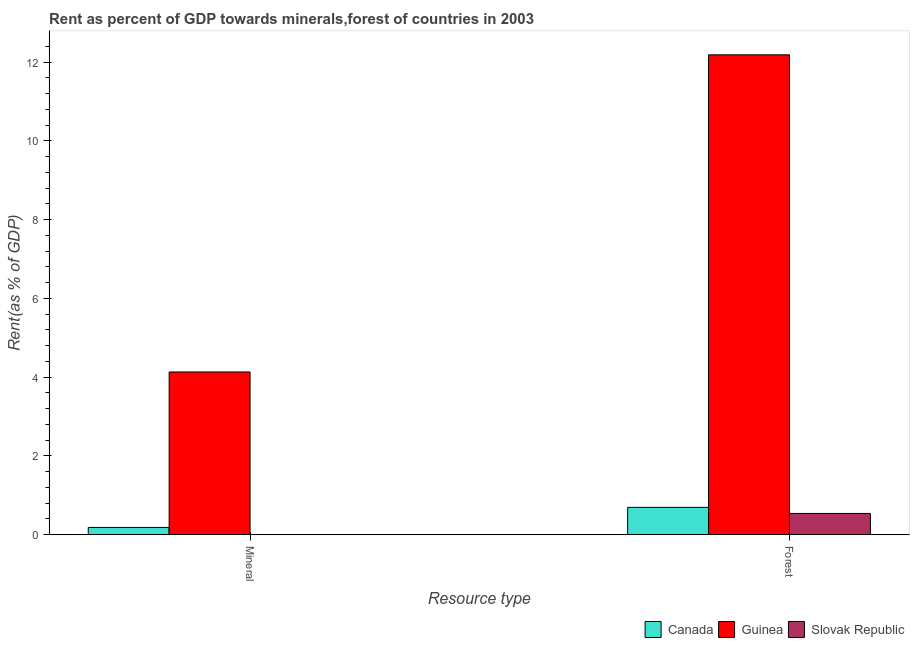How many bars are there on the 1st tick from the right?
Your response must be concise. 3. What is the label of the 1st group of bars from the left?
Your answer should be compact. Mineral. What is the forest rent in Guinea?
Keep it short and to the point. 12.18. Across all countries, what is the maximum mineral rent?
Your answer should be very brief. 4.13. Across all countries, what is the minimum forest rent?
Your answer should be compact. 0.54. In which country was the forest rent maximum?
Your answer should be very brief. Guinea. In which country was the mineral rent minimum?
Your response must be concise. Slovak Republic. What is the total mineral rent in the graph?
Offer a terse response. 4.32. What is the difference between the forest rent in Canada and that in Slovak Republic?
Provide a short and direct response. 0.15. What is the difference between the forest rent in Slovak Republic and the mineral rent in Guinea?
Provide a succinct answer. -3.59. What is the average forest rent per country?
Make the answer very short. 4.47. What is the difference between the mineral rent and forest rent in Guinea?
Offer a very short reply. -8.05. In how many countries, is the forest rent greater than 5.6 %?
Make the answer very short. 1. What is the ratio of the forest rent in Canada to that in Guinea?
Your response must be concise. 0.06. In how many countries, is the mineral rent greater than the average mineral rent taken over all countries?
Ensure brevity in your answer.  1. What does the 3rd bar from the left in Mineral represents?
Give a very brief answer. Slovak Republic. What does the 2nd bar from the right in Mineral represents?
Your answer should be compact. Guinea. How many bars are there?
Your answer should be compact. 6. How many countries are there in the graph?
Provide a succinct answer. 3. Does the graph contain any zero values?
Make the answer very short. No. Does the graph contain grids?
Keep it short and to the point. No. How many legend labels are there?
Give a very brief answer. 3. How are the legend labels stacked?
Ensure brevity in your answer.  Horizontal. What is the title of the graph?
Your answer should be compact. Rent as percent of GDP towards minerals,forest of countries in 2003. What is the label or title of the X-axis?
Offer a terse response. Resource type. What is the label or title of the Y-axis?
Make the answer very short. Rent(as % of GDP). What is the Rent(as % of GDP) in Canada in Mineral?
Provide a short and direct response. 0.18. What is the Rent(as % of GDP) in Guinea in Mineral?
Ensure brevity in your answer.  4.13. What is the Rent(as % of GDP) of Slovak Republic in Mineral?
Provide a succinct answer. 0. What is the Rent(as % of GDP) in Canada in Forest?
Make the answer very short. 0.69. What is the Rent(as % of GDP) of Guinea in Forest?
Make the answer very short. 12.18. What is the Rent(as % of GDP) of Slovak Republic in Forest?
Your response must be concise. 0.54. Across all Resource type, what is the maximum Rent(as % of GDP) in Canada?
Your response must be concise. 0.69. Across all Resource type, what is the maximum Rent(as % of GDP) in Guinea?
Give a very brief answer. 12.18. Across all Resource type, what is the maximum Rent(as % of GDP) in Slovak Republic?
Make the answer very short. 0.54. Across all Resource type, what is the minimum Rent(as % of GDP) of Canada?
Offer a very short reply. 0.18. Across all Resource type, what is the minimum Rent(as % of GDP) in Guinea?
Make the answer very short. 4.13. Across all Resource type, what is the minimum Rent(as % of GDP) of Slovak Republic?
Offer a very short reply. 0. What is the total Rent(as % of GDP) in Canada in the graph?
Give a very brief answer. 0.88. What is the total Rent(as % of GDP) in Guinea in the graph?
Offer a terse response. 16.31. What is the total Rent(as % of GDP) of Slovak Republic in the graph?
Make the answer very short. 0.54. What is the difference between the Rent(as % of GDP) of Canada in Mineral and that in Forest?
Your answer should be compact. -0.51. What is the difference between the Rent(as % of GDP) of Guinea in Mineral and that in Forest?
Give a very brief answer. -8.05. What is the difference between the Rent(as % of GDP) of Slovak Republic in Mineral and that in Forest?
Make the answer very short. -0.54. What is the difference between the Rent(as % of GDP) in Canada in Mineral and the Rent(as % of GDP) in Guinea in Forest?
Offer a terse response. -12. What is the difference between the Rent(as % of GDP) in Canada in Mineral and the Rent(as % of GDP) in Slovak Republic in Forest?
Your response must be concise. -0.36. What is the difference between the Rent(as % of GDP) in Guinea in Mineral and the Rent(as % of GDP) in Slovak Republic in Forest?
Give a very brief answer. 3.59. What is the average Rent(as % of GDP) of Canada per Resource type?
Keep it short and to the point. 0.44. What is the average Rent(as % of GDP) in Guinea per Resource type?
Your response must be concise. 8.16. What is the average Rent(as % of GDP) in Slovak Republic per Resource type?
Ensure brevity in your answer.  0.27. What is the difference between the Rent(as % of GDP) in Canada and Rent(as % of GDP) in Guinea in Mineral?
Ensure brevity in your answer.  -3.95. What is the difference between the Rent(as % of GDP) in Canada and Rent(as % of GDP) in Slovak Republic in Mineral?
Make the answer very short. 0.18. What is the difference between the Rent(as % of GDP) of Guinea and Rent(as % of GDP) of Slovak Republic in Mineral?
Give a very brief answer. 4.13. What is the difference between the Rent(as % of GDP) of Canada and Rent(as % of GDP) of Guinea in Forest?
Make the answer very short. -11.49. What is the difference between the Rent(as % of GDP) of Canada and Rent(as % of GDP) of Slovak Republic in Forest?
Provide a succinct answer. 0.15. What is the difference between the Rent(as % of GDP) in Guinea and Rent(as % of GDP) in Slovak Republic in Forest?
Provide a succinct answer. 11.64. What is the ratio of the Rent(as % of GDP) of Canada in Mineral to that in Forest?
Your answer should be very brief. 0.27. What is the ratio of the Rent(as % of GDP) in Guinea in Mineral to that in Forest?
Your answer should be compact. 0.34. What is the ratio of the Rent(as % of GDP) in Slovak Republic in Mineral to that in Forest?
Provide a succinct answer. 0. What is the difference between the highest and the second highest Rent(as % of GDP) in Canada?
Offer a very short reply. 0.51. What is the difference between the highest and the second highest Rent(as % of GDP) in Guinea?
Ensure brevity in your answer.  8.05. What is the difference between the highest and the second highest Rent(as % of GDP) in Slovak Republic?
Make the answer very short. 0.54. What is the difference between the highest and the lowest Rent(as % of GDP) in Canada?
Make the answer very short. 0.51. What is the difference between the highest and the lowest Rent(as % of GDP) of Guinea?
Provide a succinct answer. 8.05. What is the difference between the highest and the lowest Rent(as % of GDP) in Slovak Republic?
Keep it short and to the point. 0.54. 